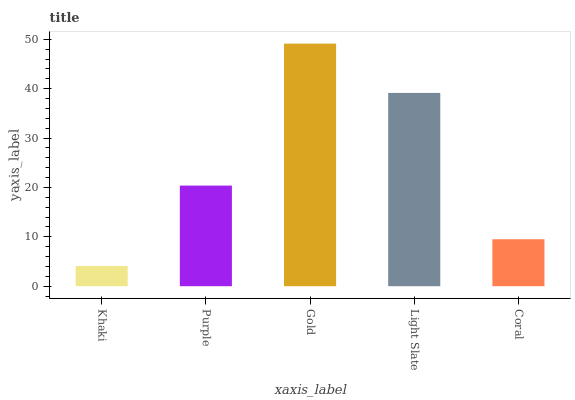Is Khaki the minimum?
Answer yes or no. Yes. Is Gold the maximum?
Answer yes or no. Yes. Is Purple the minimum?
Answer yes or no. No. Is Purple the maximum?
Answer yes or no. No. Is Purple greater than Khaki?
Answer yes or no. Yes. Is Khaki less than Purple?
Answer yes or no. Yes. Is Khaki greater than Purple?
Answer yes or no. No. Is Purple less than Khaki?
Answer yes or no. No. Is Purple the high median?
Answer yes or no. Yes. Is Purple the low median?
Answer yes or no. Yes. Is Coral the high median?
Answer yes or no. No. Is Gold the low median?
Answer yes or no. No. 